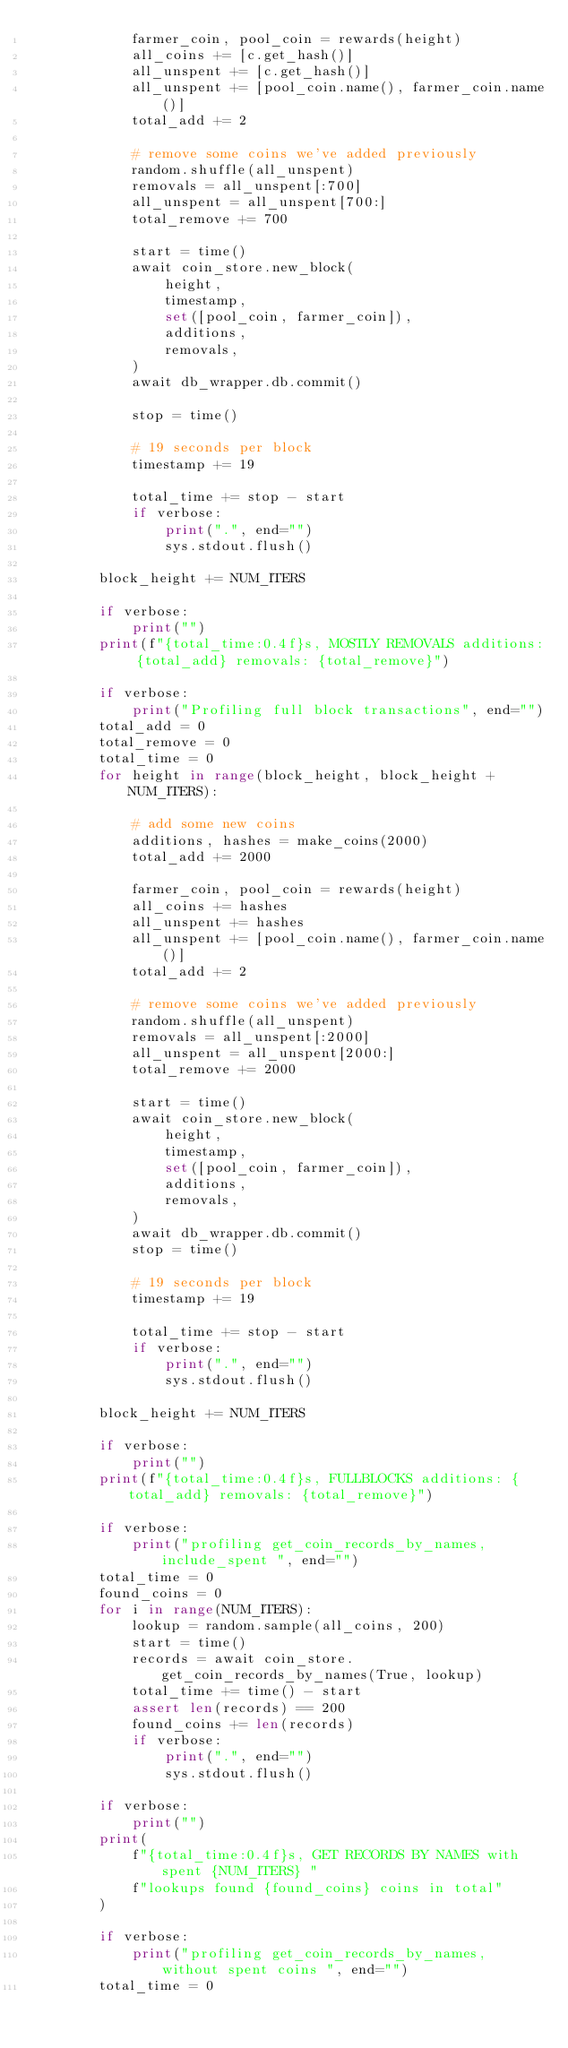Convert code to text. <code><loc_0><loc_0><loc_500><loc_500><_Python_>            farmer_coin, pool_coin = rewards(height)
            all_coins += [c.get_hash()]
            all_unspent += [c.get_hash()]
            all_unspent += [pool_coin.name(), farmer_coin.name()]
            total_add += 2

            # remove some coins we've added previously
            random.shuffle(all_unspent)
            removals = all_unspent[:700]
            all_unspent = all_unspent[700:]
            total_remove += 700

            start = time()
            await coin_store.new_block(
                height,
                timestamp,
                set([pool_coin, farmer_coin]),
                additions,
                removals,
            )
            await db_wrapper.db.commit()

            stop = time()

            # 19 seconds per block
            timestamp += 19

            total_time += stop - start
            if verbose:
                print(".", end="")
                sys.stdout.flush()

        block_height += NUM_ITERS

        if verbose:
            print("")
        print(f"{total_time:0.4f}s, MOSTLY REMOVALS additions: {total_add} removals: {total_remove}")

        if verbose:
            print("Profiling full block transactions", end="")
        total_add = 0
        total_remove = 0
        total_time = 0
        for height in range(block_height, block_height + NUM_ITERS):

            # add some new coins
            additions, hashes = make_coins(2000)
            total_add += 2000

            farmer_coin, pool_coin = rewards(height)
            all_coins += hashes
            all_unspent += hashes
            all_unspent += [pool_coin.name(), farmer_coin.name()]
            total_add += 2

            # remove some coins we've added previously
            random.shuffle(all_unspent)
            removals = all_unspent[:2000]
            all_unspent = all_unspent[2000:]
            total_remove += 2000

            start = time()
            await coin_store.new_block(
                height,
                timestamp,
                set([pool_coin, farmer_coin]),
                additions,
                removals,
            )
            await db_wrapper.db.commit()
            stop = time()

            # 19 seconds per block
            timestamp += 19

            total_time += stop - start
            if verbose:
                print(".", end="")
                sys.stdout.flush()

        block_height += NUM_ITERS

        if verbose:
            print("")
        print(f"{total_time:0.4f}s, FULLBLOCKS additions: {total_add} removals: {total_remove}")

        if verbose:
            print("profiling get_coin_records_by_names, include_spent ", end="")
        total_time = 0
        found_coins = 0
        for i in range(NUM_ITERS):
            lookup = random.sample(all_coins, 200)
            start = time()
            records = await coin_store.get_coin_records_by_names(True, lookup)
            total_time += time() - start
            assert len(records) == 200
            found_coins += len(records)
            if verbose:
                print(".", end="")
                sys.stdout.flush()

        if verbose:
            print("")
        print(
            f"{total_time:0.4f}s, GET RECORDS BY NAMES with spent {NUM_ITERS} "
            f"lookups found {found_coins} coins in total"
        )

        if verbose:
            print("profiling get_coin_records_by_names, without spent coins ", end="")
        total_time = 0</code> 